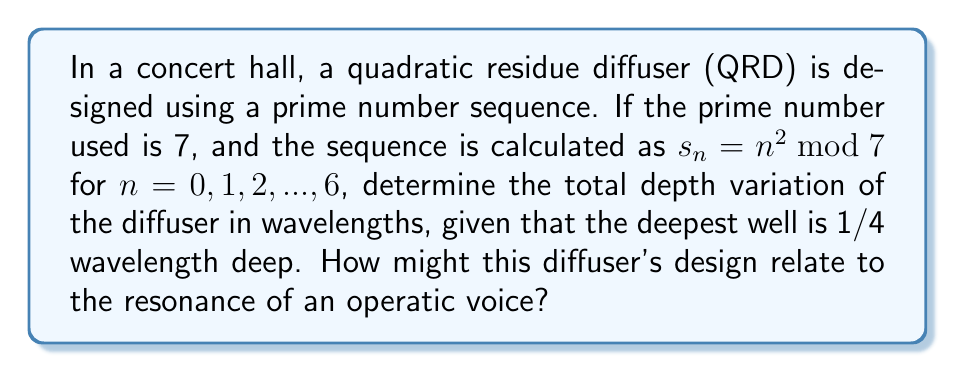Give your solution to this math problem. Let's approach this step-by-step:

1) First, we calculate the sequence $s_n = n^2 \bmod 7$ for $n = 0, 1, 2, ..., 6$:

   $s_0 = 0^2 \bmod 7 = 0$
   $s_1 = 1^2 \bmod 7 = 1$
   $s_2 = 2^2 \bmod 7 = 4$
   $s_3 = 3^2 \bmod 7 = 2$
   $s_4 = 4^2 \bmod 7 = 2$
   $s_5 = 5^2 \bmod 7 = 4$
   $s_6 = 6^2 \bmod 7 = 1$

2) The sequence is therefore [0, 1, 4, 2, 2, 4, 1].

3) To find the depth variation, we need to find the difference between the maximum and minimum values in this sequence.

   $\max(s_n) = 4$
   $\min(s_n) = 0$

4) The depth variation in terms of the sequence is:

   $4 - 0 = 4$

5) We're told that the deepest well (corresponding to the maximum value in the sequence) is 1/4 wavelength deep. So, we need to scale our depth variation:

   Depth variation in wavelengths = $\frac{4}{4} \cdot \frac{1}{4} = \frac{1}{4}$

6) Relating to an operatic voice: This diffuser design creates a complex reflection pattern that helps disperse sound evenly throughout the concert hall. For an opera singer, this means that their voice will be heard clearly and with consistent volume throughout the audience, enhancing the emotional impact and healing power of their performance.
Answer: $\frac{1}{4}$ wavelength 